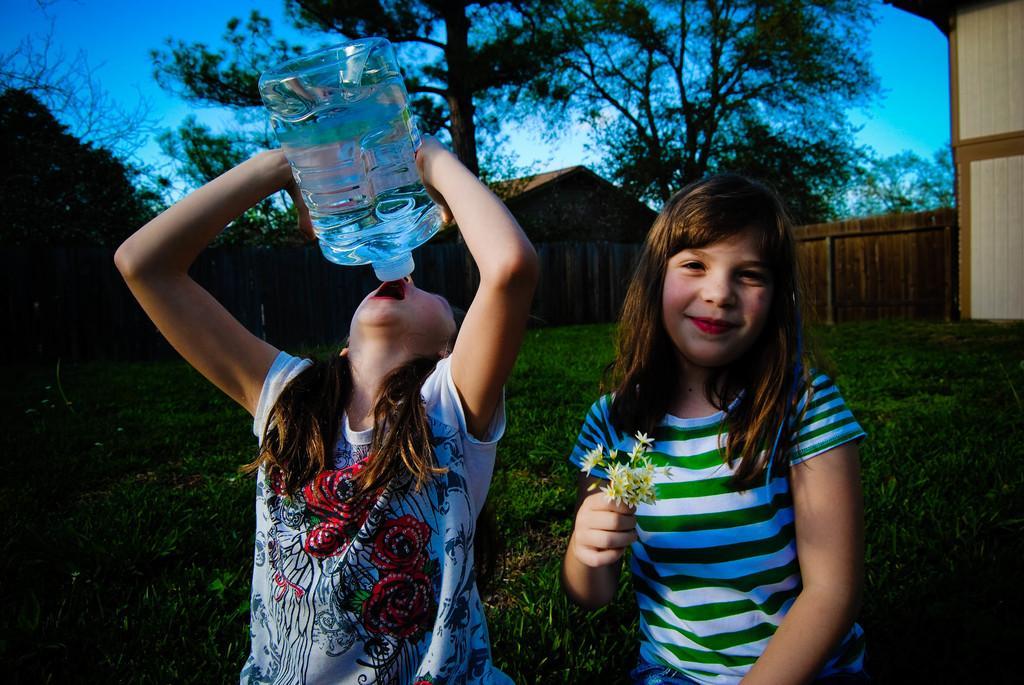In one or two sentences, can you explain what this image depicts? In front of the picture, we see two girls are standing. The girl on the left side is trying to drink water from the water can. Beside her, we see a girl is holding the flowers. She is smiling and she might be posing for the photo. Behind them, we see the grass. There are trees and buildings in the background. At the top, we see the sky, which is blue in color. 